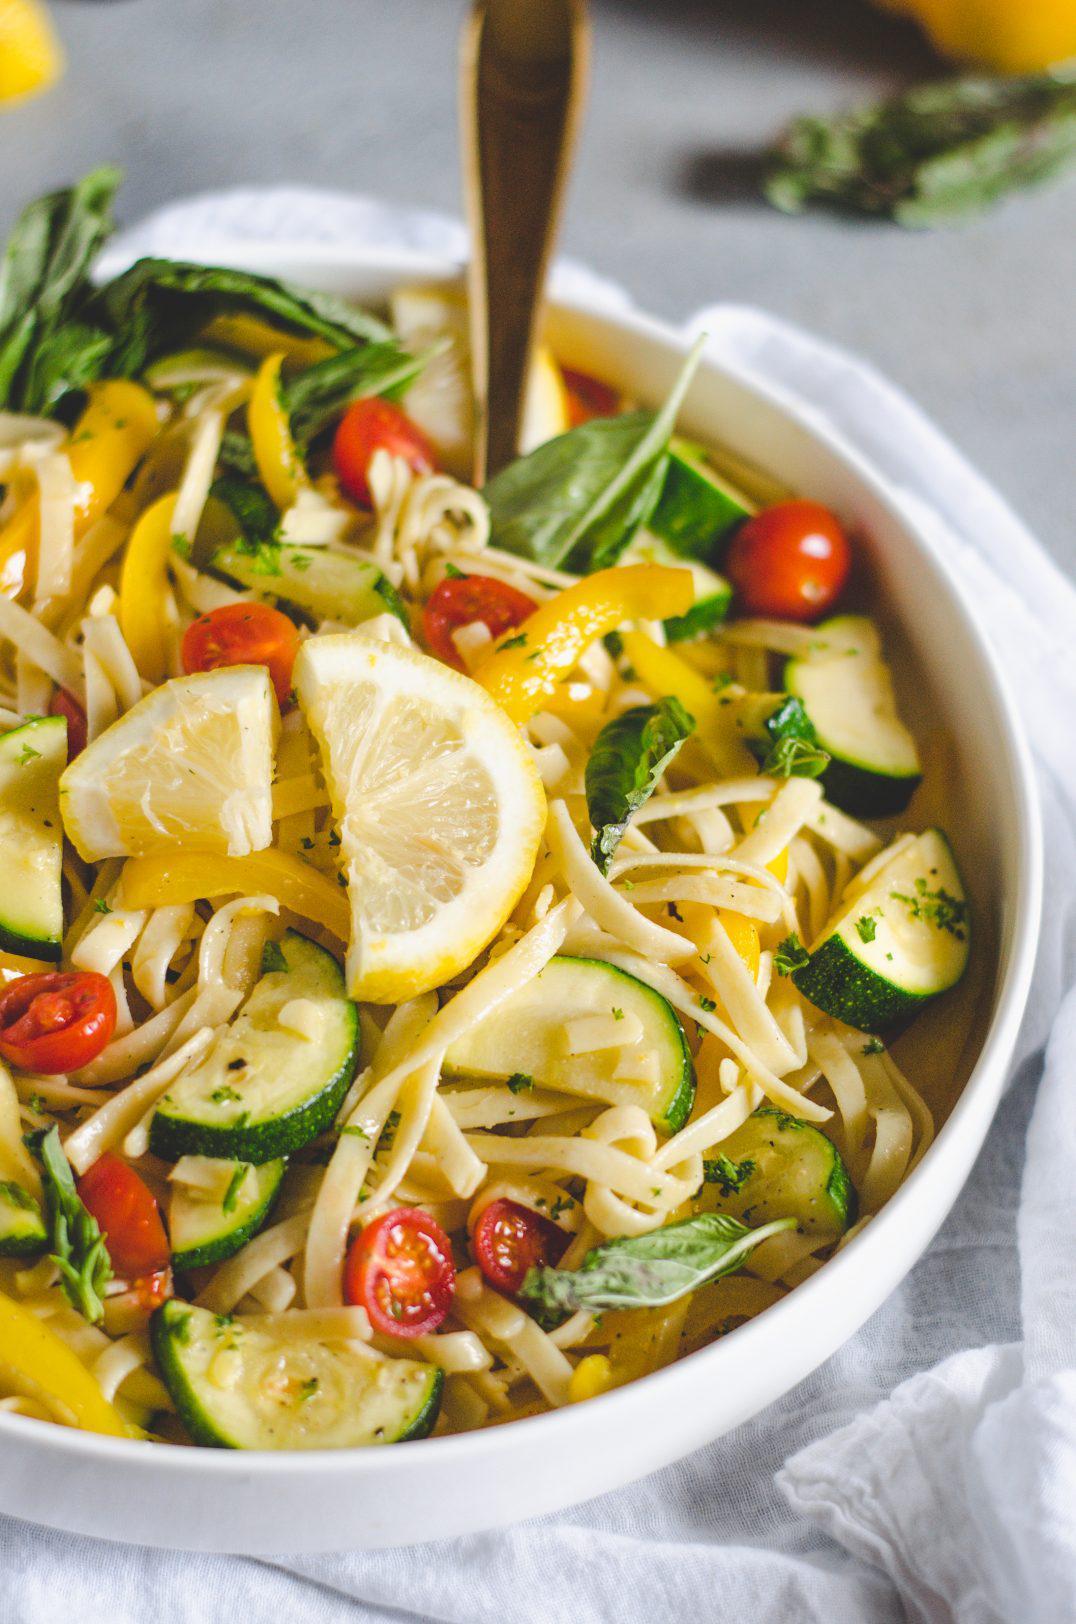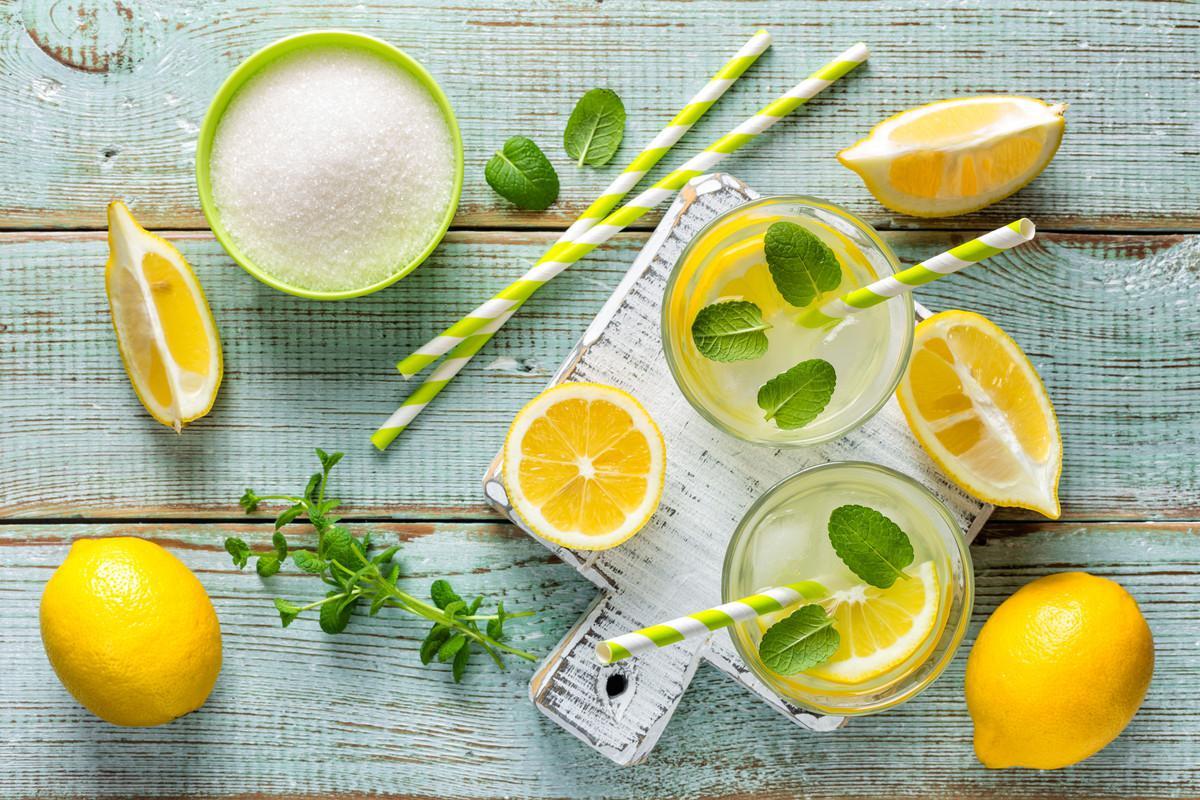The first image is the image on the left, the second image is the image on the right. Considering the images on both sides, is "One spoon is resting in a bowl of food containing lemons." valid? Answer yes or no. Yes. The first image is the image on the left, the second image is the image on the right. For the images shown, is this caption "One image features a scattered display on a painted wood surface that includes whole lemons, cut lemons, and green leaves." true? Answer yes or no. Yes. 